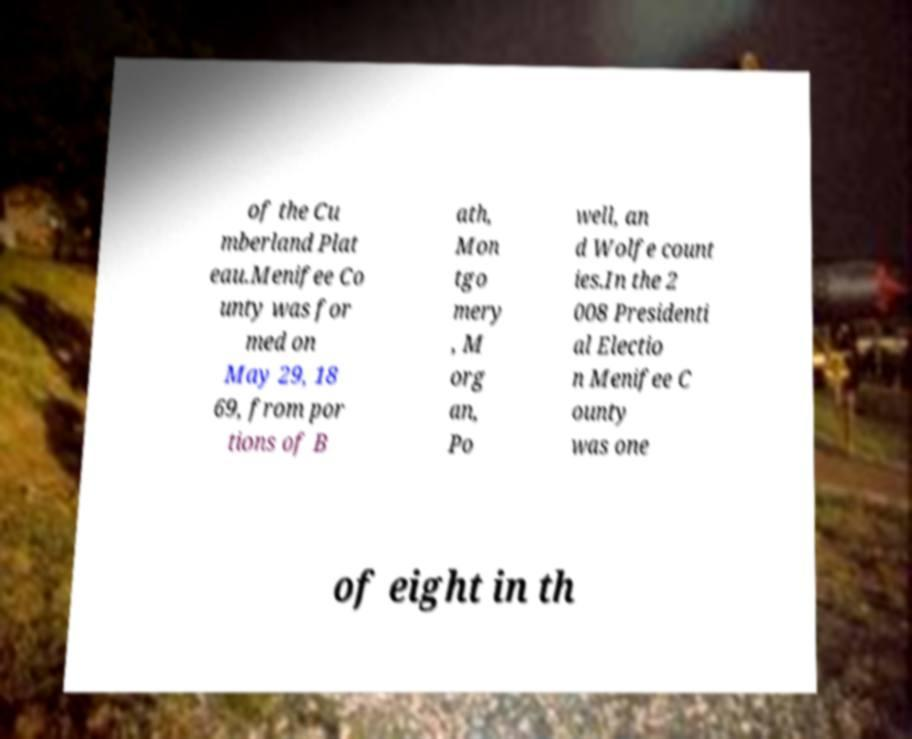For documentation purposes, I need the text within this image transcribed. Could you provide that? of the Cu mberland Plat eau.Menifee Co unty was for med on May 29, 18 69, from por tions of B ath, Mon tgo mery , M org an, Po well, an d Wolfe count ies.In the 2 008 Presidenti al Electio n Menifee C ounty was one of eight in th 